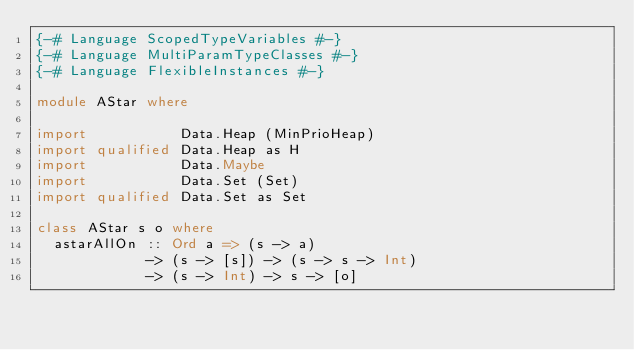<code> <loc_0><loc_0><loc_500><loc_500><_Haskell_>{-# Language ScopedTypeVariables #-}
{-# Language MultiParamTypeClasses #-}
{-# Language FlexibleInstances #-}

module AStar where

import           Data.Heap (MinPrioHeap)
import qualified Data.Heap as H
import           Data.Maybe
import           Data.Set (Set)
import qualified Data.Set as Set

class AStar s o where
  astarAllOn :: Ord a => (s -> a)
             -> (s -> [s]) -> (s -> s -> Int)
             -> (s -> Int) -> s -> [o]
</code> 